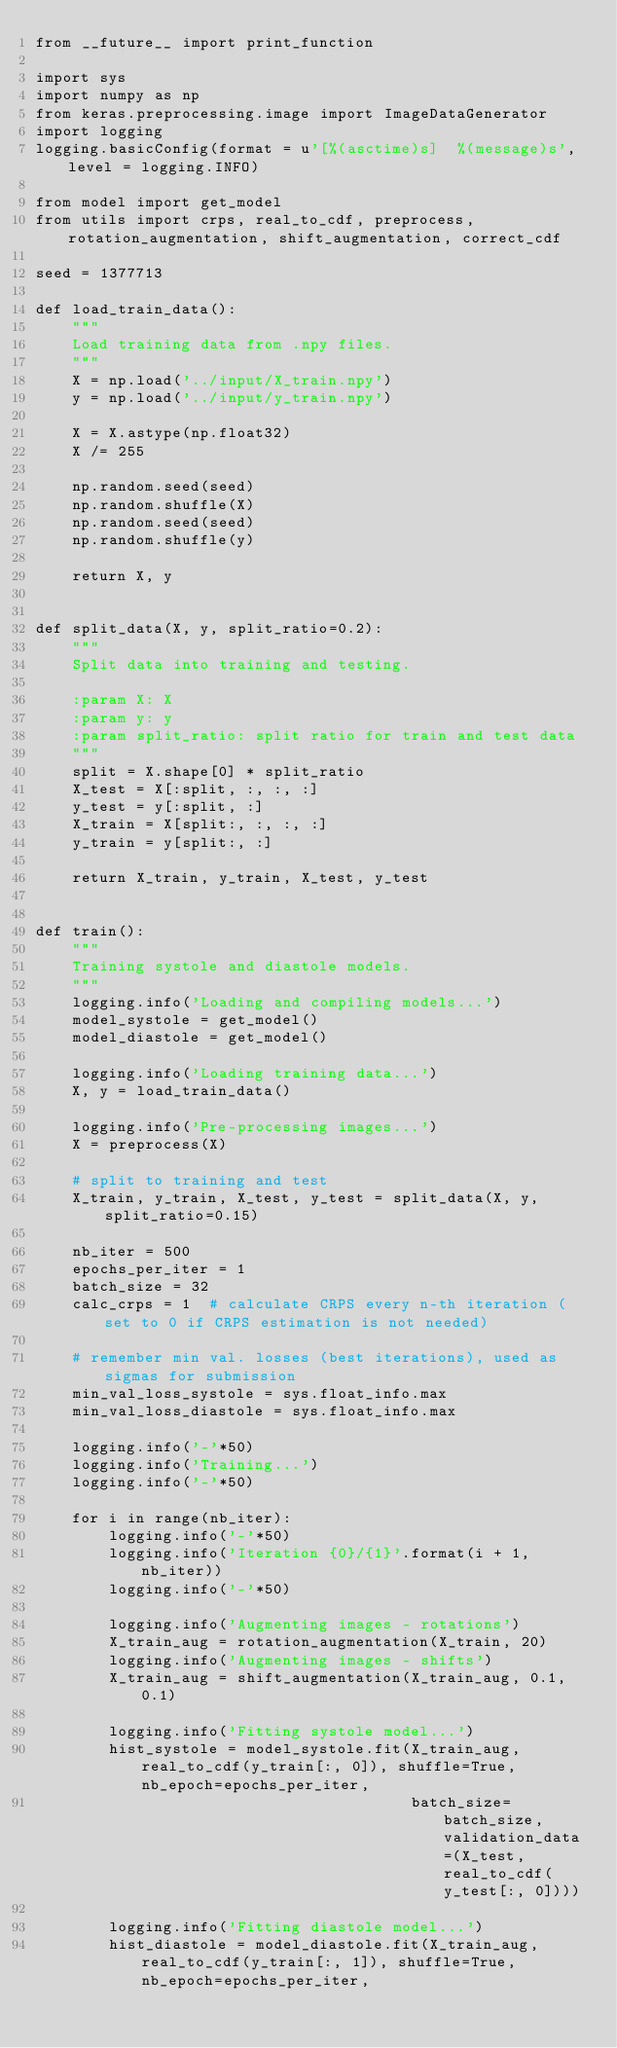<code> <loc_0><loc_0><loc_500><loc_500><_Python_>from __future__ import print_function

import sys
import numpy as np
from keras.preprocessing.image import ImageDataGenerator
import logging
logging.basicConfig(format = u'[%(asctime)s]  %(message)s', level = logging.INFO)

from model import get_model
from utils import crps, real_to_cdf, preprocess, rotation_augmentation, shift_augmentation, correct_cdf

seed = 1377713

def load_train_data():
    """
    Load training data from .npy files.
    """
    X = np.load('../input/X_train.npy')
    y = np.load('../input/y_train.npy')

    X = X.astype(np.float32)
    X /= 255

    np.random.seed(seed)
    np.random.shuffle(X)
    np.random.seed(seed)
    np.random.shuffle(y)

    return X, y


def split_data(X, y, split_ratio=0.2):
    """
    Split data into training and testing.

    :param X: X
    :param y: y
    :param split_ratio: split ratio for train and test data
    """
    split = X.shape[0] * split_ratio
    X_test = X[:split, :, :, :]
    y_test = y[:split, :]
    X_train = X[split:, :, :, :]
    y_train = y[split:, :]

    return X_train, y_train, X_test, y_test


def train():
    """
    Training systole and diastole models.
    """
    logging.info('Loading and compiling models...')
    model_systole = get_model()
    model_diastole = get_model()

    logging.info('Loading training data...')
    X, y = load_train_data()

    logging.info('Pre-processing images...')
    X = preprocess(X)

    # split to training and test
    X_train, y_train, X_test, y_test = split_data(X, y, split_ratio=0.15)

    nb_iter = 500
    epochs_per_iter = 1
    batch_size = 32
    calc_crps = 1  # calculate CRPS every n-th iteration (set to 0 if CRPS estimation is not needed)

    # remember min val. losses (best iterations), used as sigmas for submission
    min_val_loss_systole = sys.float_info.max
    min_val_loss_diastole = sys.float_info.max

    logging.info('-'*50)
    logging.info('Training...')
    logging.info('-'*50)

    for i in range(nb_iter):
        logging.info('-'*50)
        logging.info('Iteration {0}/{1}'.format(i + 1, nb_iter))
        logging.info('-'*50)

        logging.info('Augmenting images - rotations')
        X_train_aug = rotation_augmentation(X_train, 20)
        logging.info('Augmenting images - shifts')
        X_train_aug = shift_augmentation(X_train_aug, 0.1, 0.1)

        logging.info('Fitting systole model...')
        hist_systole = model_systole.fit(X_train_aug, real_to_cdf(y_train[:, 0]), shuffle=True, nb_epoch=epochs_per_iter,
                                         batch_size=batch_size, validation_data=(X_test, real_to_cdf(y_test[:, 0])))

        logging.info('Fitting diastole model...')
        hist_diastole = model_diastole.fit(X_train_aug, real_to_cdf(y_train[:, 1]), shuffle=True, nb_epoch=epochs_per_iter,</code> 